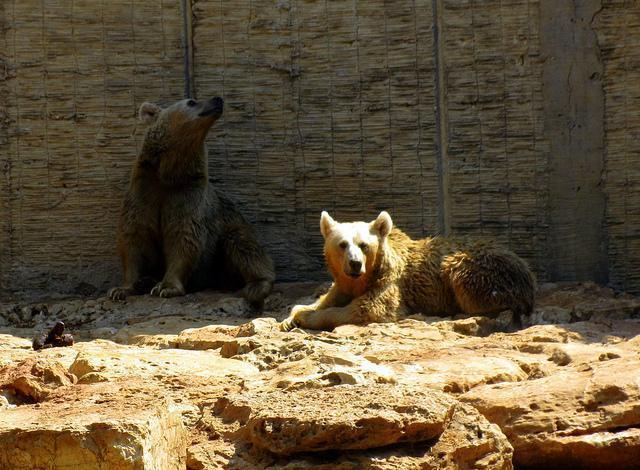How many bears are there?
Give a very brief answer. 2. 